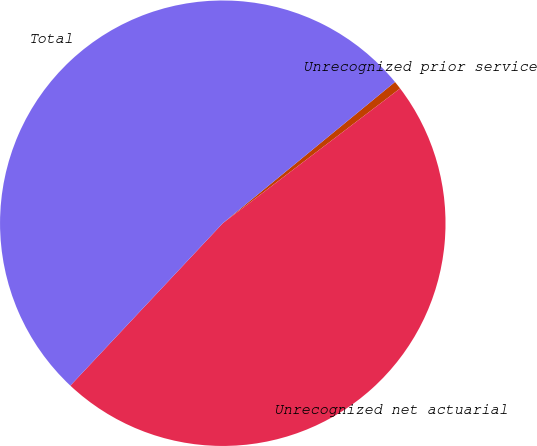Convert chart to OTSL. <chart><loc_0><loc_0><loc_500><loc_500><pie_chart><fcel>Unrecognized prior service<fcel>Unrecognized net actuarial<fcel>Total<nl><fcel>0.59%<fcel>47.34%<fcel>52.07%<nl></chart> 